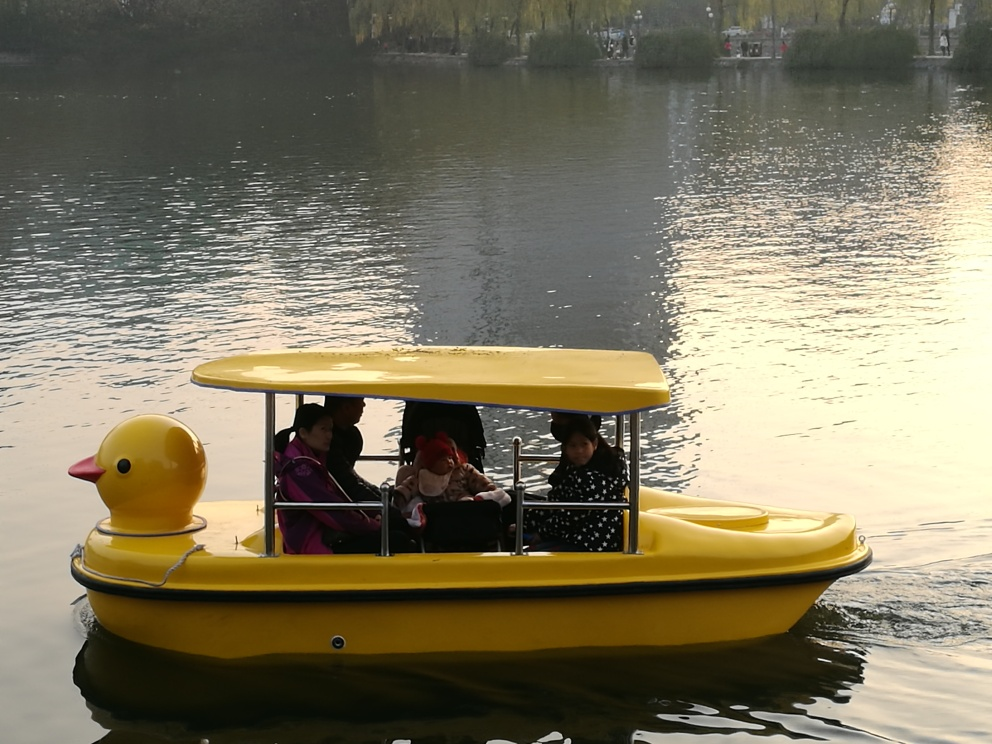What time of day does it seem to be in this image? Considering the warm, soft quality of the light and the long shadows present, it appears to be either early morning or late afternoon, times commonly associated with the golden hour in photography. 